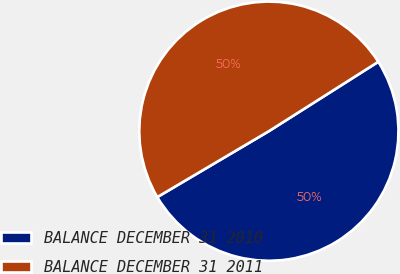<chart> <loc_0><loc_0><loc_500><loc_500><pie_chart><fcel>BALANCE DECEMBER 31 2010<fcel>BALANCE DECEMBER 31 2011<nl><fcel>50.5%<fcel>49.5%<nl></chart> 